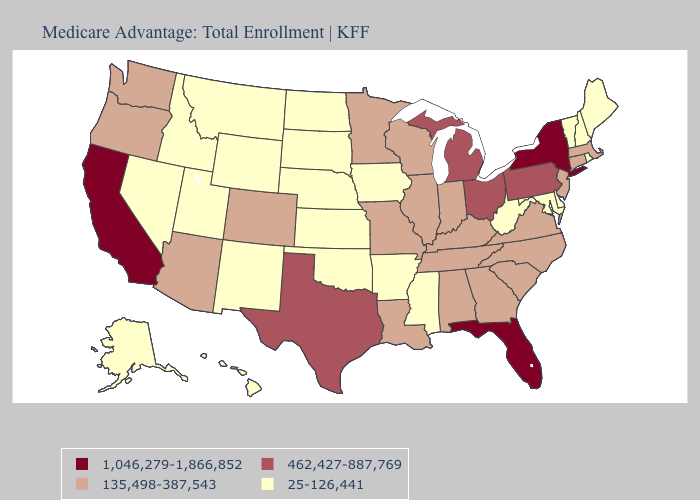Which states have the lowest value in the USA?
Keep it brief. Alaska, Arkansas, Delaware, Hawaii, Iowa, Idaho, Kansas, Maryland, Maine, Mississippi, Montana, North Dakota, Nebraska, New Hampshire, New Mexico, Nevada, Oklahoma, Rhode Island, South Dakota, Utah, Vermont, West Virginia, Wyoming. Does Massachusetts have the lowest value in the USA?
Concise answer only. No. What is the highest value in states that border New Jersey?
Give a very brief answer. 1,046,279-1,866,852. What is the lowest value in the USA?
Be succinct. 25-126,441. What is the value of Colorado?
Write a very short answer. 135,498-387,543. Among the states that border Georgia , which have the highest value?
Write a very short answer. Florida. Which states have the lowest value in the MidWest?
Be succinct. Iowa, Kansas, North Dakota, Nebraska, South Dakota. Name the states that have a value in the range 1,046,279-1,866,852?
Be succinct. California, Florida, New York. What is the value of Idaho?
Be succinct. 25-126,441. Which states hav the highest value in the MidWest?
Keep it brief. Michigan, Ohio. Is the legend a continuous bar?
Answer briefly. No. Name the states that have a value in the range 25-126,441?
Keep it brief. Alaska, Arkansas, Delaware, Hawaii, Iowa, Idaho, Kansas, Maryland, Maine, Mississippi, Montana, North Dakota, Nebraska, New Hampshire, New Mexico, Nevada, Oklahoma, Rhode Island, South Dakota, Utah, Vermont, West Virginia, Wyoming. What is the lowest value in the USA?
Keep it brief. 25-126,441. What is the highest value in the South ?
Short answer required. 1,046,279-1,866,852. What is the lowest value in states that border Maryland?
Concise answer only. 25-126,441. 